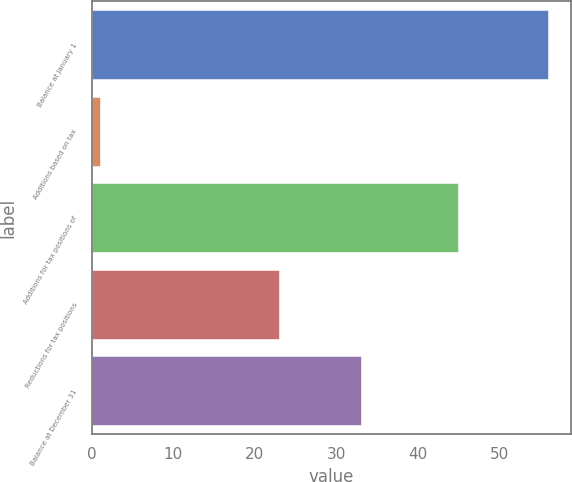<chart> <loc_0><loc_0><loc_500><loc_500><bar_chart><fcel>Balance at January 1<fcel>Additions based on tax<fcel>Additions for tax positions of<fcel>Reductions for tax positions<fcel>Balance at December 31<nl><fcel>56<fcel>1<fcel>45<fcel>23<fcel>33<nl></chart> 